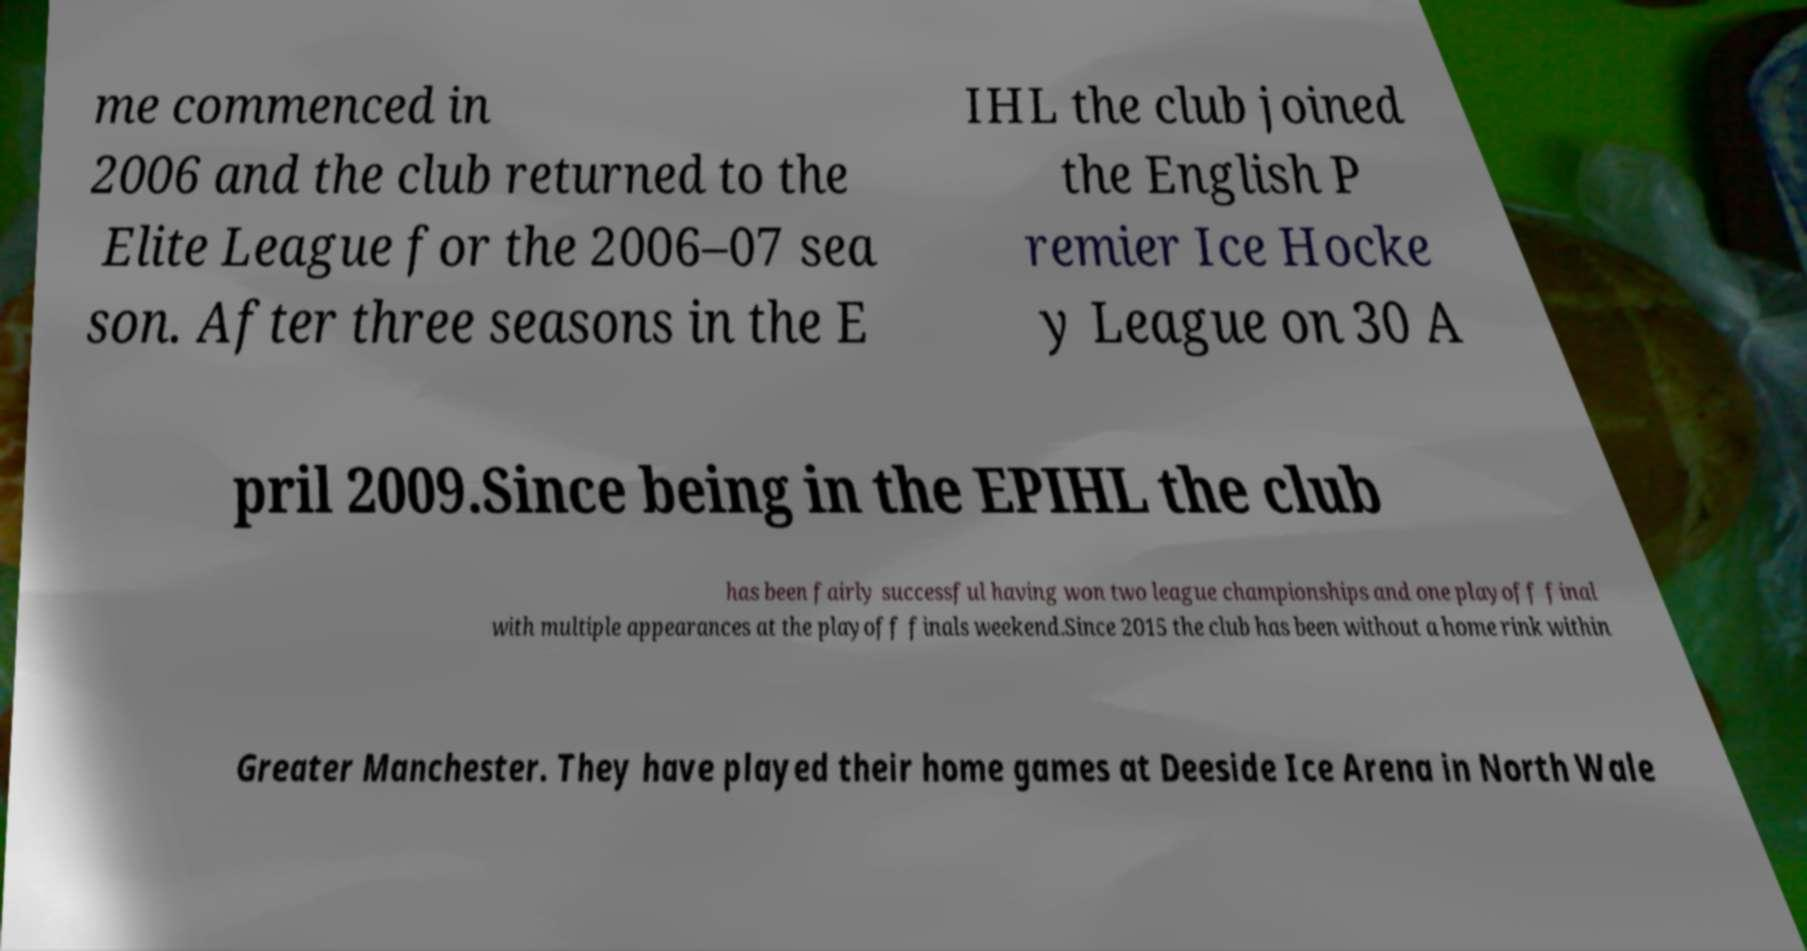Could you extract and type out the text from this image? me commenced in 2006 and the club returned to the Elite League for the 2006–07 sea son. After three seasons in the E IHL the club joined the English P remier Ice Hocke y League on 30 A pril 2009.Since being in the EPIHL the club has been fairly successful having won two league championships and one playoff final with multiple appearances at the playoff finals weekend.Since 2015 the club has been without a home rink within Greater Manchester. They have played their home games at Deeside Ice Arena in North Wale 